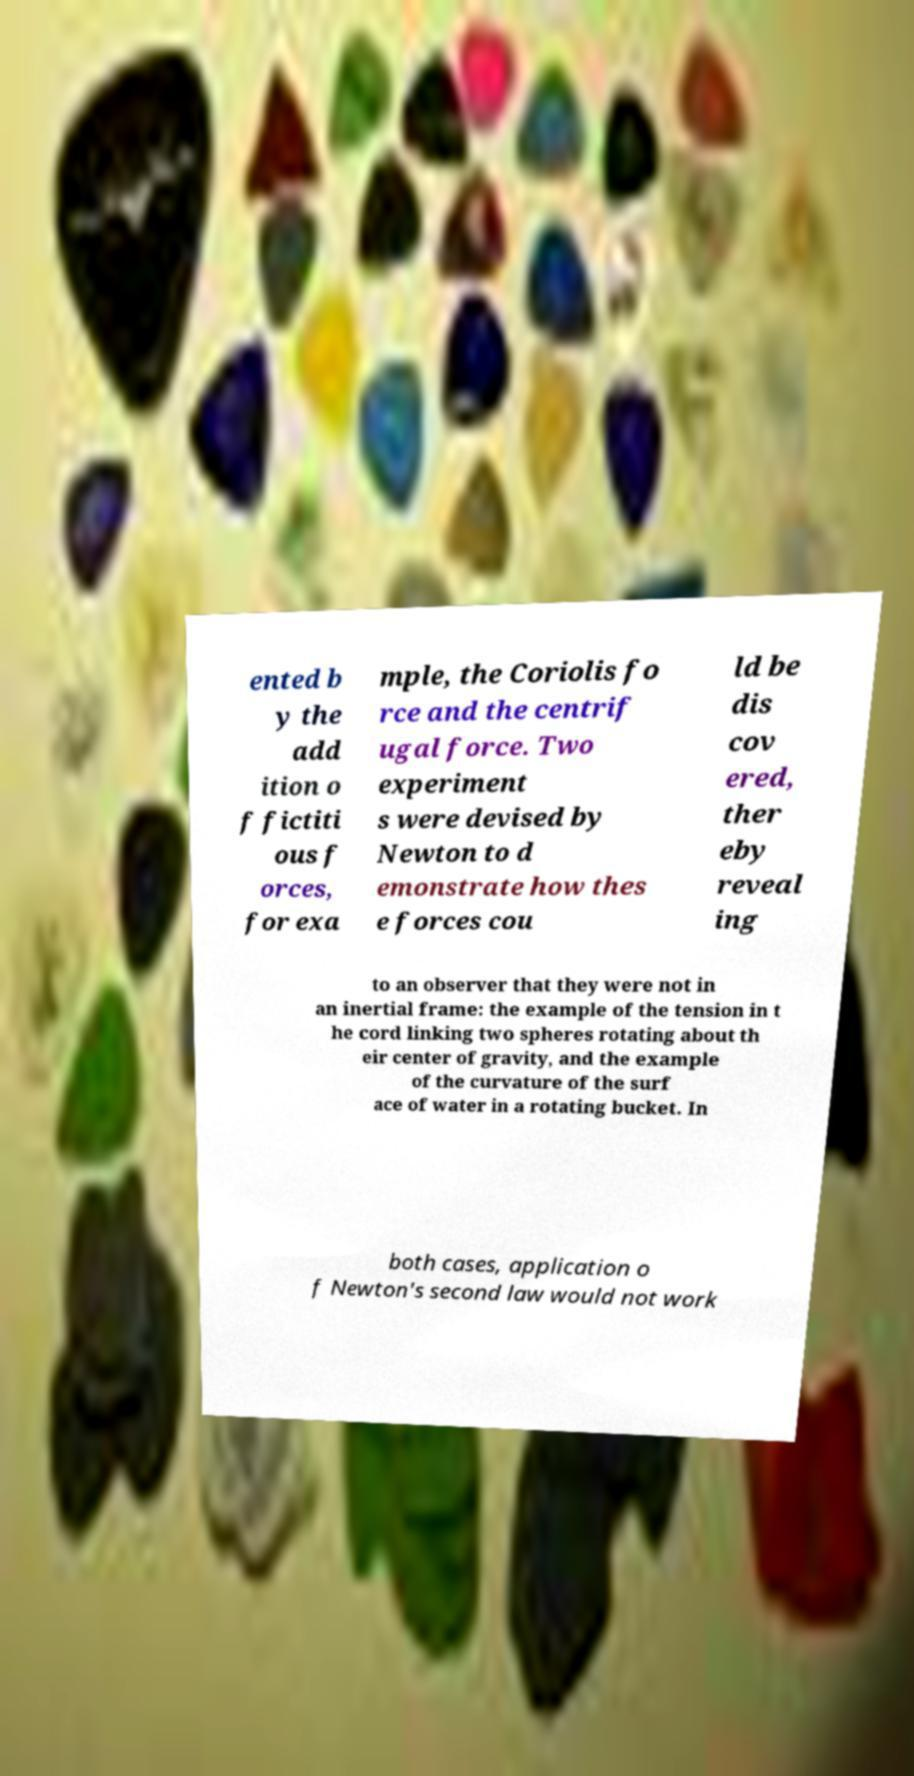Can you accurately transcribe the text from the provided image for me? ented b y the add ition o f fictiti ous f orces, for exa mple, the Coriolis fo rce and the centrif ugal force. Two experiment s were devised by Newton to d emonstrate how thes e forces cou ld be dis cov ered, ther eby reveal ing to an observer that they were not in an inertial frame: the example of the tension in t he cord linking two spheres rotating about th eir center of gravity, and the example of the curvature of the surf ace of water in a rotating bucket. In both cases, application o f Newton's second law would not work 